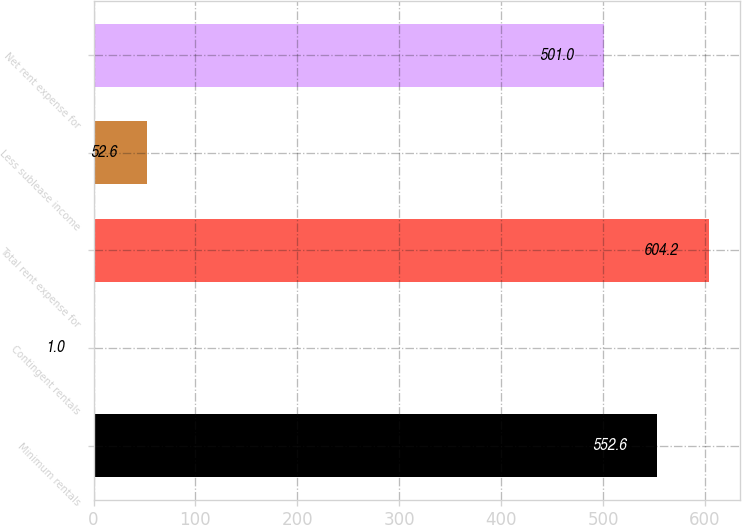Convert chart. <chart><loc_0><loc_0><loc_500><loc_500><bar_chart><fcel>Minimum rentals<fcel>Contingent rentals<fcel>Total rent expense for<fcel>Less sublease income<fcel>Net rent expense for<nl><fcel>552.6<fcel>1<fcel>604.2<fcel>52.6<fcel>501<nl></chart> 